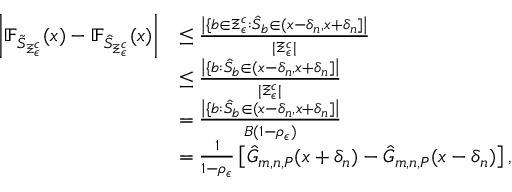Convert formula to latex. <formula><loc_0><loc_0><loc_500><loc_500>\begin{array} { r l } { \left | \mathbb { F } _ { \tilde { S } _ { \Xi _ { \epsilon } ^ { c } } } ( x ) - \mathbb { F } _ { \hat { S } _ { \Xi _ { \epsilon } ^ { c } } } ( x ) \right | } & { \leq \frac { \left | \{ b \in \Xi _ { \epsilon } ^ { c } \colon \hat { S } _ { b } \in ( x - \delta _ { n } , x + \delta _ { n } ] \right | } { | \Xi _ { \epsilon } ^ { c } | } } \\ & { \leq \frac { \left | \{ b \colon \hat { S } _ { b } \in ( x - \delta _ { n } , x + \delta _ { n } ] \right | } { | \Xi _ { \epsilon } ^ { c } | } } \\ & { = \frac { \left | \{ b \colon \hat { S } _ { b } \in ( x - \delta _ { n } , x + \delta _ { n } ] \right | } { B ( 1 - \rho _ { \epsilon } ) } } \\ & { = \frac { 1 } { 1 - \rho _ { \epsilon } } \left [ \hat { G } _ { m , n , P } ( x + \delta _ { n } ) - \hat { G } _ { m , n , P } ( x - \delta _ { n } ) \right ] , } \end{array}</formula> 